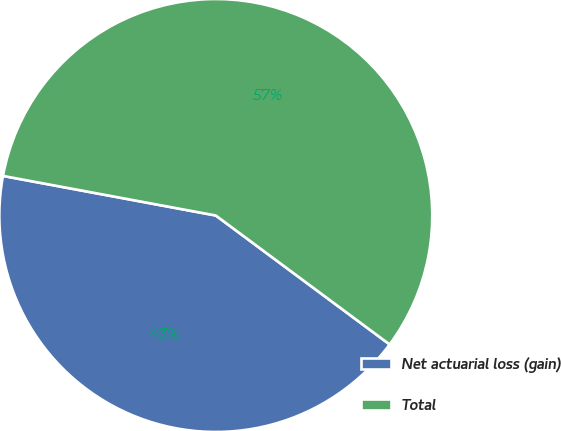Convert chart. <chart><loc_0><loc_0><loc_500><loc_500><pie_chart><fcel>Net actuarial loss (gain)<fcel>Total<nl><fcel>42.77%<fcel>57.23%<nl></chart> 